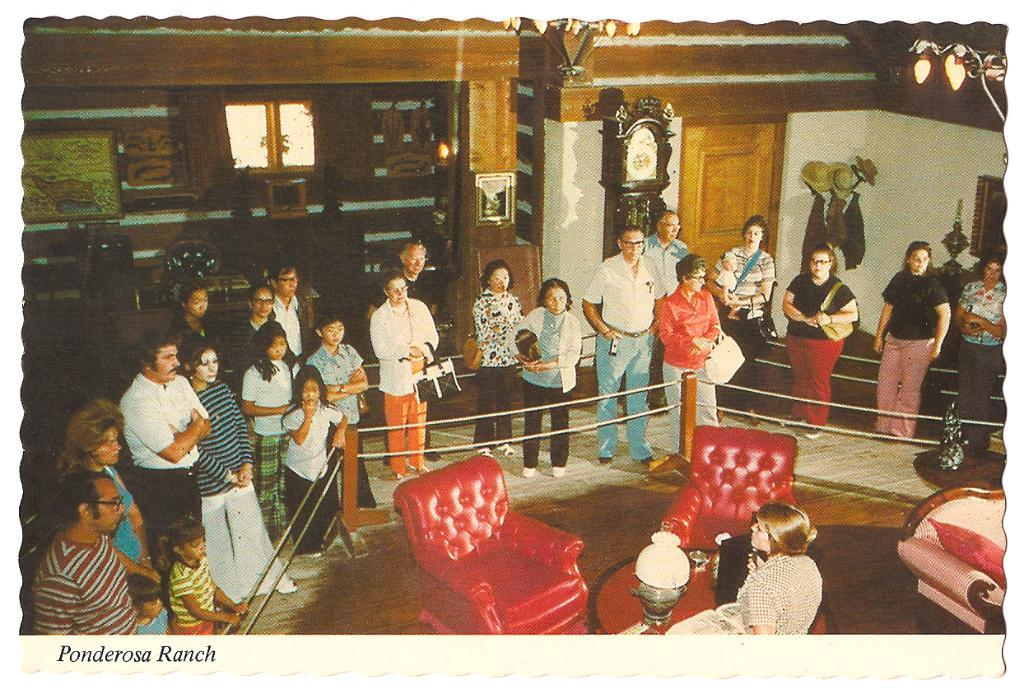Provide a one-sentence caption for the provided image. A group gathers to hear remarks by a speaker in a historic house. 